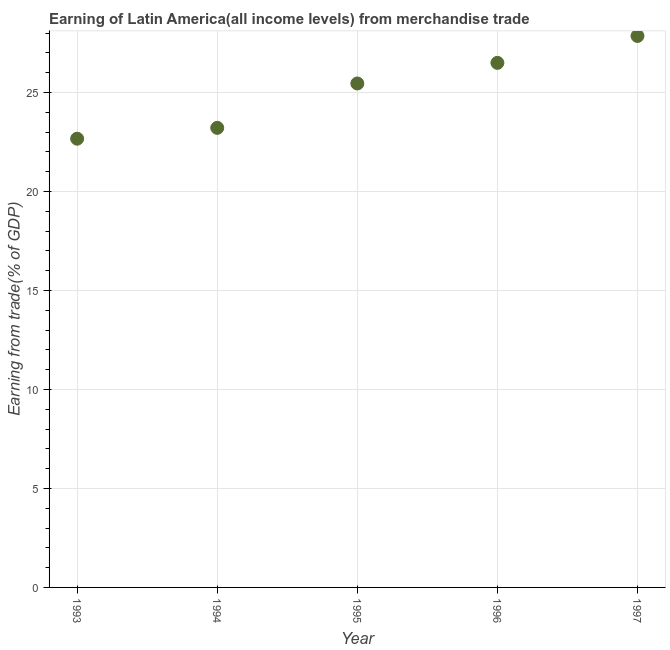What is the earning from merchandise trade in 1996?
Offer a very short reply. 26.5. Across all years, what is the maximum earning from merchandise trade?
Make the answer very short. 27.85. Across all years, what is the minimum earning from merchandise trade?
Your answer should be very brief. 22.67. In which year was the earning from merchandise trade minimum?
Give a very brief answer. 1993. What is the sum of the earning from merchandise trade?
Give a very brief answer. 125.68. What is the difference between the earning from merchandise trade in 1993 and 1997?
Keep it short and to the point. -5.19. What is the average earning from merchandise trade per year?
Offer a very short reply. 25.14. What is the median earning from merchandise trade?
Your answer should be compact. 25.45. What is the ratio of the earning from merchandise trade in 1996 to that in 1997?
Your response must be concise. 0.95. Is the earning from merchandise trade in 1993 less than that in 1995?
Your answer should be very brief. Yes. Is the difference between the earning from merchandise trade in 1993 and 1996 greater than the difference between any two years?
Give a very brief answer. No. What is the difference between the highest and the second highest earning from merchandise trade?
Your answer should be very brief. 1.36. Is the sum of the earning from merchandise trade in 1993 and 1994 greater than the maximum earning from merchandise trade across all years?
Make the answer very short. Yes. What is the difference between the highest and the lowest earning from merchandise trade?
Ensure brevity in your answer.  5.19. In how many years, is the earning from merchandise trade greater than the average earning from merchandise trade taken over all years?
Your answer should be compact. 3. How many dotlines are there?
Provide a succinct answer. 1. How many years are there in the graph?
Your answer should be compact. 5. Are the values on the major ticks of Y-axis written in scientific E-notation?
Provide a short and direct response. No. Does the graph contain any zero values?
Make the answer very short. No. What is the title of the graph?
Ensure brevity in your answer.  Earning of Latin America(all income levels) from merchandise trade. What is the label or title of the Y-axis?
Your answer should be compact. Earning from trade(% of GDP). What is the Earning from trade(% of GDP) in 1993?
Ensure brevity in your answer.  22.67. What is the Earning from trade(% of GDP) in 1994?
Give a very brief answer. 23.21. What is the Earning from trade(% of GDP) in 1995?
Keep it short and to the point. 25.45. What is the Earning from trade(% of GDP) in 1996?
Make the answer very short. 26.5. What is the Earning from trade(% of GDP) in 1997?
Offer a very short reply. 27.85. What is the difference between the Earning from trade(% of GDP) in 1993 and 1994?
Provide a succinct answer. -0.55. What is the difference between the Earning from trade(% of GDP) in 1993 and 1995?
Offer a very short reply. -2.79. What is the difference between the Earning from trade(% of GDP) in 1993 and 1996?
Provide a succinct answer. -3.83. What is the difference between the Earning from trade(% of GDP) in 1993 and 1997?
Give a very brief answer. -5.19. What is the difference between the Earning from trade(% of GDP) in 1994 and 1995?
Your answer should be compact. -2.24. What is the difference between the Earning from trade(% of GDP) in 1994 and 1996?
Keep it short and to the point. -3.28. What is the difference between the Earning from trade(% of GDP) in 1994 and 1997?
Provide a short and direct response. -4.64. What is the difference between the Earning from trade(% of GDP) in 1995 and 1996?
Provide a succinct answer. -1.04. What is the difference between the Earning from trade(% of GDP) in 1995 and 1997?
Your response must be concise. -2.4. What is the difference between the Earning from trade(% of GDP) in 1996 and 1997?
Give a very brief answer. -1.36. What is the ratio of the Earning from trade(% of GDP) in 1993 to that in 1995?
Make the answer very short. 0.89. What is the ratio of the Earning from trade(% of GDP) in 1993 to that in 1996?
Give a very brief answer. 0.85. What is the ratio of the Earning from trade(% of GDP) in 1993 to that in 1997?
Provide a succinct answer. 0.81. What is the ratio of the Earning from trade(% of GDP) in 1994 to that in 1995?
Your answer should be compact. 0.91. What is the ratio of the Earning from trade(% of GDP) in 1994 to that in 1996?
Your answer should be compact. 0.88. What is the ratio of the Earning from trade(% of GDP) in 1994 to that in 1997?
Ensure brevity in your answer.  0.83. What is the ratio of the Earning from trade(% of GDP) in 1995 to that in 1996?
Provide a succinct answer. 0.96. What is the ratio of the Earning from trade(% of GDP) in 1995 to that in 1997?
Your response must be concise. 0.91. What is the ratio of the Earning from trade(% of GDP) in 1996 to that in 1997?
Give a very brief answer. 0.95. 